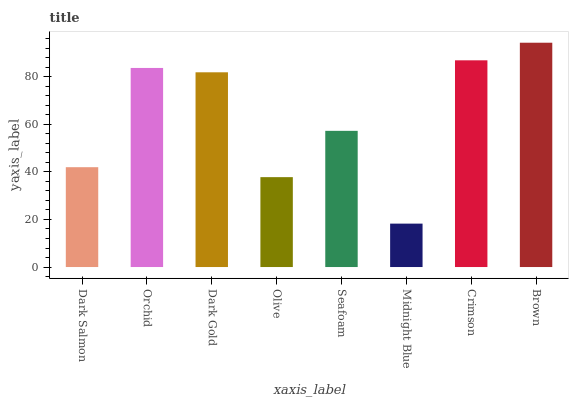Is Midnight Blue the minimum?
Answer yes or no. Yes. Is Brown the maximum?
Answer yes or no. Yes. Is Orchid the minimum?
Answer yes or no. No. Is Orchid the maximum?
Answer yes or no. No. Is Orchid greater than Dark Salmon?
Answer yes or no. Yes. Is Dark Salmon less than Orchid?
Answer yes or no. Yes. Is Dark Salmon greater than Orchid?
Answer yes or no. No. Is Orchid less than Dark Salmon?
Answer yes or no. No. Is Dark Gold the high median?
Answer yes or no. Yes. Is Seafoam the low median?
Answer yes or no. Yes. Is Seafoam the high median?
Answer yes or no. No. Is Dark Gold the low median?
Answer yes or no. No. 